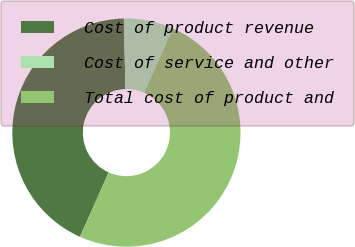Convert chart. <chart><loc_0><loc_0><loc_500><loc_500><pie_chart><fcel>Cost of product revenue<fcel>Cost of service and other<fcel>Total cost of product and<nl><fcel>42.97%<fcel>7.03%<fcel>50.0%<nl></chart> 